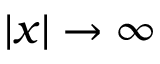<formula> <loc_0><loc_0><loc_500><loc_500>| x | \rightarrow \infty</formula> 